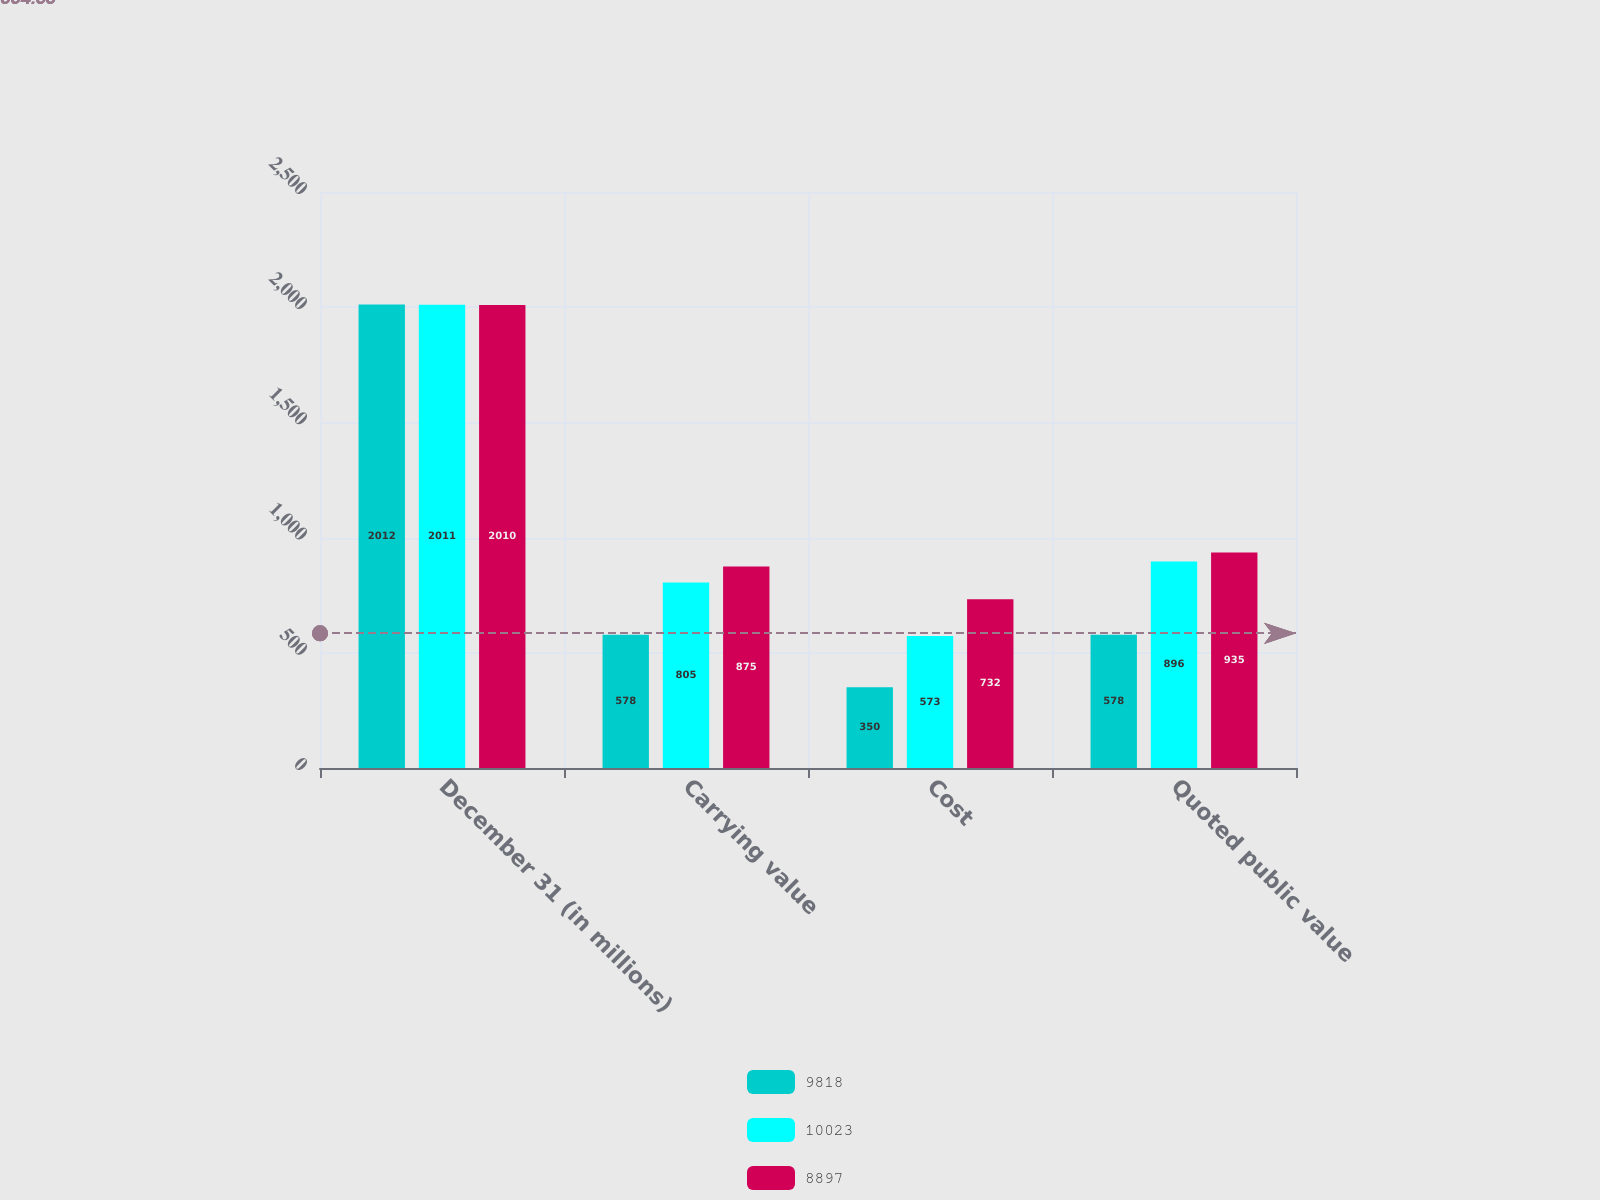Convert chart. <chart><loc_0><loc_0><loc_500><loc_500><stacked_bar_chart><ecel><fcel>December 31 (in millions)<fcel>Carrying value<fcel>Cost<fcel>Quoted public value<nl><fcel>9818<fcel>2012<fcel>578<fcel>350<fcel>578<nl><fcel>10023<fcel>2011<fcel>805<fcel>573<fcel>896<nl><fcel>8897<fcel>2010<fcel>875<fcel>732<fcel>935<nl></chart> 